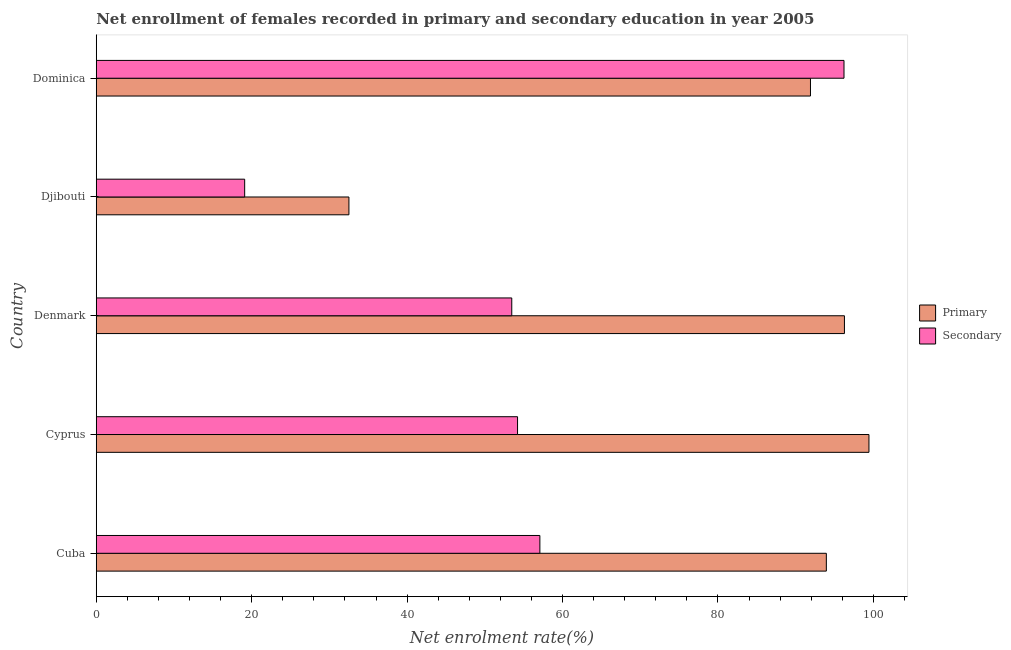Are the number of bars on each tick of the Y-axis equal?
Your answer should be compact. Yes. How many bars are there on the 1st tick from the top?
Provide a succinct answer. 2. How many bars are there on the 2nd tick from the bottom?
Offer a terse response. 2. What is the label of the 1st group of bars from the top?
Provide a succinct answer. Dominica. What is the enrollment rate in primary education in Dominica?
Your answer should be compact. 91.91. Across all countries, what is the maximum enrollment rate in secondary education?
Offer a very short reply. 96.22. Across all countries, what is the minimum enrollment rate in secondary education?
Make the answer very short. 19.1. In which country was the enrollment rate in secondary education maximum?
Provide a succinct answer. Dominica. In which country was the enrollment rate in primary education minimum?
Provide a short and direct response. Djibouti. What is the total enrollment rate in primary education in the graph?
Your answer should be very brief. 414.09. What is the difference between the enrollment rate in secondary education in Denmark and that in Djibouti?
Keep it short and to the point. 34.37. What is the difference between the enrollment rate in secondary education in Cyprus and the enrollment rate in primary education in Djibouti?
Provide a succinct answer. 21.7. What is the average enrollment rate in secondary education per country?
Your answer should be very brief. 56.02. What is the difference between the enrollment rate in primary education and enrollment rate in secondary education in Cyprus?
Offer a very short reply. 45.22. What is the ratio of the enrollment rate in secondary education in Denmark to that in Dominica?
Offer a terse response. 0.56. What is the difference between the highest and the second highest enrollment rate in secondary education?
Offer a terse response. 39.14. What is the difference between the highest and the lowest enrollment rate in primary education?
Your answer should be very brief. 66.92. What does the 2nd bar from the top in Cuba represents?
Provide a succinct answer. Primary. What does the 1st bar from the bottom in Denmark represents?
Keep it short and to the point. Primary. How many bars are there?
Give a very brief answer. 10. Are all the bars in the graph horizontal?
Your answer should be very brief. Yes. How many countries are there in the graph?
Your response must be concise. 5. What is the difference between two consecutive major ticks on the X-axis?
Provide a short and direct response. 20. Are the values on the major ticks of X-axis written in scientific E-notation?
Your response must be concise. No. Does the graph contain any zero values?
Your answer should be compact. No. Where does the legend appear in the graph?
Your answer should be very brief. Center right. How are the legend labels stacked?
Give a very brief answer. Vertical. What is the title of the graph?
Give a very brief answer. Net enrollment of females recorded in primary and secondary education in year 2005. Does "Savings" appear as one of the legend labels in the graph?
Provide a succinct answer. No. What is the label or title of the X-axis?
Offer a terse response. Net enrolment rate(%). What is the label or title of the Y-axis?
Offer a very short reply. Country. What is the Net enrolment rate(%) of Primary in Cuba?
Provide a succinct answer. 93.95. What is the Net enrolment rate(%) in Secondary in Cuba?
Give a very brief answer. 57.09. What is the Net enrolment rate(%) of Primary in Cyprus?
Make the answer very short. 99.44. What is the Net enrolment rate(%) in Secondary in Cyprus?
Your response must be concise. 54.21. What is the Net enrolment rate(%) in Primary in Denmark?
Your response must be concise. 96.28. What is the Net enrolment rate(%) in Secondary in Denmark?
Offer a very short reply. 53.47. What is the Net enrolment rate(%) of Primary in Djibouti?
Your answer should be compact. 32.51. What is the Net enrolment rate(%) in Secondary in Djibouti?
Make the answer very short. 19.1. What is the Net enrolment rate(%) of Primary in Dominica?
Provide a short and direct response. 91.91. What is the Net enrolment rate(%) of Secondary in Dominica?
Provide a succinct answer. 96.22. Across all countries, what is the maximum Net enrolment rate(%) in Primary?
Your answer should be compact. 99.44. Across all countries, what is the maximum Net enrolment rate(%) in Secondary?
Keep it short and to the point. 96.22. Across all countries, what is the minimum Net enrolment rate(%) in Primary?
Your answer should be very brief. 32.51. Across all countries, what is the minimum Net enrolment rate(%) of Secondary?
Keep it short and to the point. 19.1. What is the total Net enrolment rate(%) of Primary in the graph?
Offer a terse response. 414.09. What is the total Net enrolment rate(%) of Secondary in the graph?
Give a very brief answer. 280.09. What is the difference between the Net enrolment rate(%) of Primary in Cuba and that in Cyprus?
Your answer should be very brief. -5.48. What is the difference between the Net enrolment rate(%) of Secondary in Cuba and that in Cyprus?
Offer a terse response. 2.87. What is the difference between the Net enrolment rate(%) of Primary in Cuba and that in Denmark?
Your response must be concise. -2.33. What is the difference between the Net enrolment rate(%) in Secondary in Cuba and that in Denmark?
Provide a short and direct response. 3.62. What is the difference between the Net enrolment rate(%) in Primary in Cuba and that in Djibouti?
Offer a very short reply. 61.44. What is the difference between the Net enrolment rate(%) in Secondary in Cuba and that in Djibouti?
Make the answer very short. 37.99. What is the difference between the Net enrolment rate(%) of Primary in Cuba and that in Dominica?
Keep it short and to the point. 2.04. What is the difference between the Net enrolment rate(%) of Secondary in Cuba and that in Dominica?
Offer a very short reply. -39.14. What is the difference between the Net enrolment rate(%) of Primary in Cyprus and that in Denmark?
Provide a short and direct response. 3.15. What is the difference between the Net enrolment rate(%) of Secondary in Cyprus and that in Denmark?
Give a very brief answer. 0.74. What is the difference between the Net enrolment rate(%) in Primary in Cyprus and that in Djibouti?
Keep it short and to the point. 66.92. What is the difference between the Net enrolment rate(%) of Secondary in Cyprus and that in Djibouti?
Provide a short and direct response. 35.12. What is the difference between the Net enrolment rate(%) of Primary in Cyprus and that in Dominica?
Keep it short and to the point. 7.53. What is the difference between the Net enrolment rate(%) in Secondary in Cyprus and that in Dominica?
Provide a succinct answer. -42.01. What is the difference between the Net enrolment rate(%) in Primary in Denmark and that in Djibouti?
Provide a short and direct response. 63.77. What is the difference between the Net enrolment rate(%) in Secondary in Denmark and that in Djibouti?
Your answer should be compact. 34.37. What is the difference between the Net enrolment rate(%) in Primary in Denmark and that in Dominica?
Your answer should be compact. 4.37. What is the difference between the Net enrolment rate(%) of Secondary in Denmark and that in Dominica?
Your answer should be very brief. -42.75. What is the difference between the Net enrolment rate(%) of Primary in Djibouti and that in Dominica?
Your response must be concise. -59.4. What is the difference between the Net enrolment rate(%) in Secondary in Djibouti and that in Dominica?
Provide a short and direct response. -77.13. What is the difference between the Net enrolment rate(%) in Primary in Cuba and the Net enrolment rate(%) in Secondary in Cyprus?
Offer a very short reply. 39.74. What is the difference between the Net enrolment rate(%) of Primary in Cuba and the Net enrolment rate(%) of Secondary in Denmark?
Keep it short and to the point. 40.48. What is the difference between the Net enrolment rate(%) in Primary in Cuba and the Net enrolment rate(%) in Secondary in Djibouti?
Make the answer very short. 74.85. What is the difference between the Net enrolment rate(%) of Primary in Cuba and the Net enrolment rate(%) of Secondary in Dominica?
Your answer should be compact. -2.27. What is the difference between the Net enrolment rate(%) of Primary in Cyprus and the Net enrolment rate(%) of Secondary in Denmark?
Ensure brevity in your answer.  45.96. What is the difference between the Net enrolment rate(%) of Primary in Cyprus and the Net enrolment rate(%) of Secondary in Djibouti?
Give a very brief answer. 80.34. What is the difference between the Net enrolment rate(%) of Primary in Cyprus and the Net enrolment rate(%) of Secondary in Dominica?
Your response must be concise. 3.21. What is the difference between the Net enrolment rate(%) in Primary in Denmark and the Net enrolment rate(%) in Secondary in Djibouti?
Provide a succinct answer. 77.18. What is the difference between the Net enrolment rate(%) of Primary in Denmark and the Net enrolment rate(%) of Secondary in Dominica?
Provide a short and direct response. 0.06. What is the difference between the Net enrolment rate(%) in Primary in Djibouti and the Net enrolment rate(%) in Secondary in Dominica?
Your answer should be very brief. -63.71. What is the average Net enrolment rate(%) of Primary per country?
Offer a terse response. 82.82. What is the average Net enrolment rate(%) in Secondary per country?
Provide a succinct answer. 56.02. What is the difference between the Net enrolment rate(%) in Primary and Net enrolment rate(%) in Secondary in Cuba?
Make the answer very short. 36.87. What is the difference between the Net enrolment rate(%) of Primary and Net enrolment rate(%) of Secondary in Cyprus?
Offer a very short reply. 45.22. What is the difference between the Net enrolment rate(%) of Primary and Net enrolment rate(%) of Secondary in Denmark?
Your answer should be compact. 42.81. What is the difference between the Net enrolment rate(%) in Primary and Net enrolment rate(%) in Secondary in Djibouti?
Ensure brevity in your answer.  13.42. What is the difference between the Net enrolment rate(%) in Primary and Net enrolment rate(%) in Secondary in Dominica?
Your response must be concise. -4.31. What is the ratio of the Net enrolment rate(%) of Primary in Cuba to that in Cyprus?
Your answer should be compact. 0.94. What is the ratio of the Net enrolment rate(%) of Secondary in Cuba to that in Cyprus?
Keep it short and to the point. 1.05. What is the ratio of the Net enrolment rate(%) of Primary in Cuba to that in Denmark?
Provide a succinct answer. 0.98. What is the ratio of the Net enrolment rate(%) of Secondary in Cuba to that in Denmark?
Give a very brief answer. 1.07. What is the ratio of the Net enrolment rate(%) in Primary in Cuba to that in Djibouti?
Your answer should be compact. 2.89. What is the ratio of the Net enrolment rate(%) of Secondary in Cuba to that in Djibouti?
Offer a very short reply. 2.99. What is the ratio of the Net enrolment rate(%) in Primary in Cuba to that in Dominica?
Give a very brief answer. 1.02. What is the ratio of the Net enrolment rate(%) of Secondary in Cuba to that in Dominica?
Provide a short and direct response. 0.59. What is the ratio of the Net enrolment rate(%) in Primary in Cyprus to that in Denmark?
Your response must be concise. 1.03. What is the ratio of the Net enrolment rate(%) of Secondary in Cyprus to that in Denmark?
Give a very brief answer. 1.01. What is the ratio of the Net enrolment rate(%) in Primary in Cyprus to that in Djibouti?
Keep it short and to the point. 3.06. What is the ratio of the Net enrolment rate(%) in Secondary in Cyprus to that in Djibouti?
Offer a terse response. 2.84. What is the ratio of the Net enrolment rate(%) in Primary in Cyprus to that in Dominica?
Your answer should be very brief. 1.08. What is the ratio of the Net enrolment rate(%) of Secondary in Cyprus to that in Dominica?
Your response must be concise. 0.56. What is the ratio of the Net enrolment rate(%) of Primary in Denmark to that in Djibouti?
Give a very brief answer. 2.96. What is the ratio of the Net enrolment rate(%) in Secondary in Denmark to that in Djibouti?
Make the answer very short. 2.8. What is the ratio of the Net enrolment rate(%) in Primary in Denmark to that in Dominica?
Offer a very short reply. 1.05. What is the ratio of the Net enrolment rate(%) of Secondary in Denmark to that in Dominica?
Ensure brevity in your answer.  0.56. What is the ratio of the Net enrolment rate(%) in Primary in Djibouti to that in Dominica?
Your answer should be compact. 0.35. What is the ratio of the Net enrolment rate(%) in Secondary in Djibouti to that in Dominica?
Give a very brief answer. 0.2. What is the difference between the highest and the second highest Net enrolment rate(%) in Primary?
Make the answer very short. 3.15. What is the difference between the highest and the second highest Net enrolment rate(%) in Secondary?
Provide a short and direct response. 39.14. What is the difference between the highest and the lowest Net enrolment rate(%) in Primary?
Your response must be concise. 66.92. What is the difference between the highest and the lowest Net enrolment rate(%) of Secondary?
Offer a terse response. 77.13. 